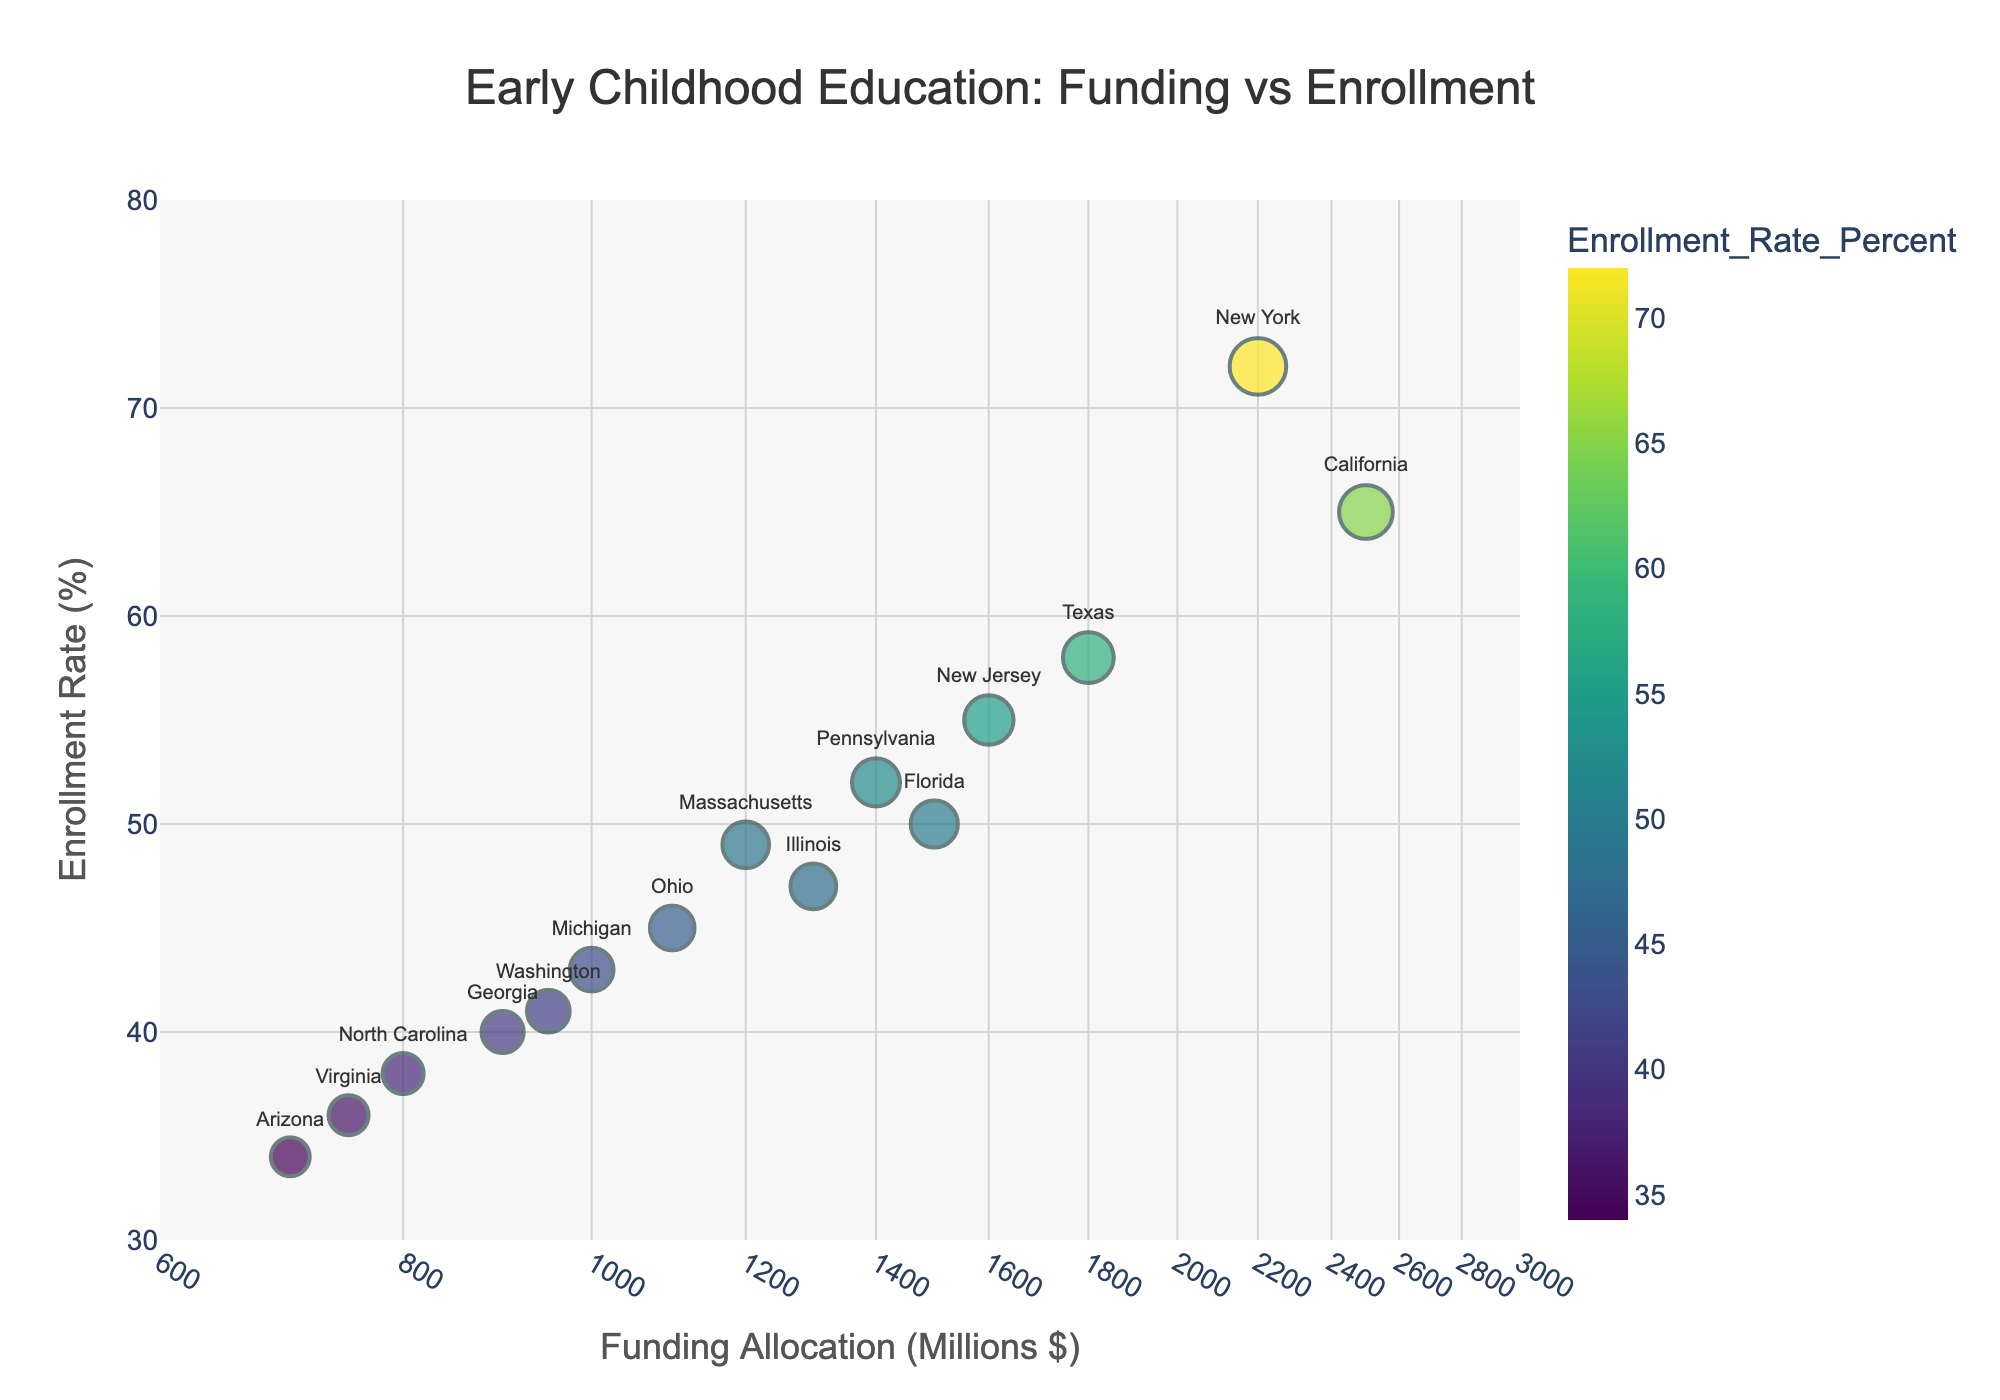What is the title of the scatter plot? The title is usually positioned at the top center of the figure and provides an overview of what the plot is about. It reads "Early Childhood Education: Funding vs Enrollment".
Answer: Early Childhood Education: Funding vs Enrollment What is the enrollment rate percentage for New York? Locate New York on the scatter plot by finding the label next to the data point and look at its y-axis value. The label for New York shows an enrollment rate of 72%.
Answer: 72% Which state has the lowest funding allocation for early childhood education? To determine this, check the x-axis values (Funding Allocation) in a log scale. The state with the data point farthest to the left on the x-axis is Arizona with a funding allocation of $700 million.
Answer: Arizona What is the average enrollment rate for states with over $1500 million in funding? Identify the states with funding allocations over $1500 million: California (65%), Texas (58%), New York (72%), and Florida (50%). Calculate their average enrollment rate: (65 + 58 + 72 + 50) / 4 = 61.25%.
Answer: 61.25% Which state has the highest enrollment rate? Locate the data point with the highest y-axis value (Enrollment Rate). New York has the highest enrollment rate of 72%.
Answer: New York Compare the enrollment rates of California and Texas. Which state has a higher rate and by how much? Look for California and Texas on the scatter plot. California has an enrollment rate of 65% and Texas has 58%. Subtract the two values to find the difference: 65 - 58 = 7%.
Answer: California by 7% Is there any state with an enrollment rate below 40%? Check the y-axis values to see if any data point is below 40%. Only Arizona and Virginia fall below 40%, with enrollment rates of 34% and 36%, respectively.
Answer: Yes, Arizona and Virginia What is the range of funding allocations for the states on this plot? Find the minimum and maximum x-axis values (Funding Allocation). The minimum funding allocation is for Arizona at $700 million, and the maximum is for California at $2500 million. The range is $2500 - $700 = $1800 million.
Answer: $1800 million Which states have an enrollment rate between 50% and 60%? Identify the states with y-axis values within this range. Texas (58%), Florida (50%), and New Jersey (55%) have enrollment rates between 50% and 60%.
Answer: Texas, Florida, New Jersey Does a higher funding allocation correlate with a higher enrollment rate? Observing the scatter plot, states with higher funding allocations generally exhibit higher enrollment rates, indicating a positive correlation.
Answer: Yes 